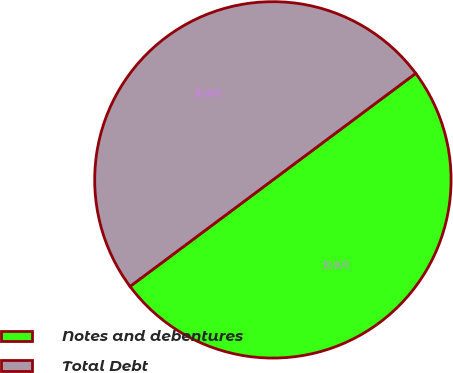<chart> <loc_0><loc_0><loc_500><loc_500><pie_chart><fcel>Notes and debentures<fcel>Total Debt<nl><fcel>50.0%<fcel>50.0%<nl></chart> 